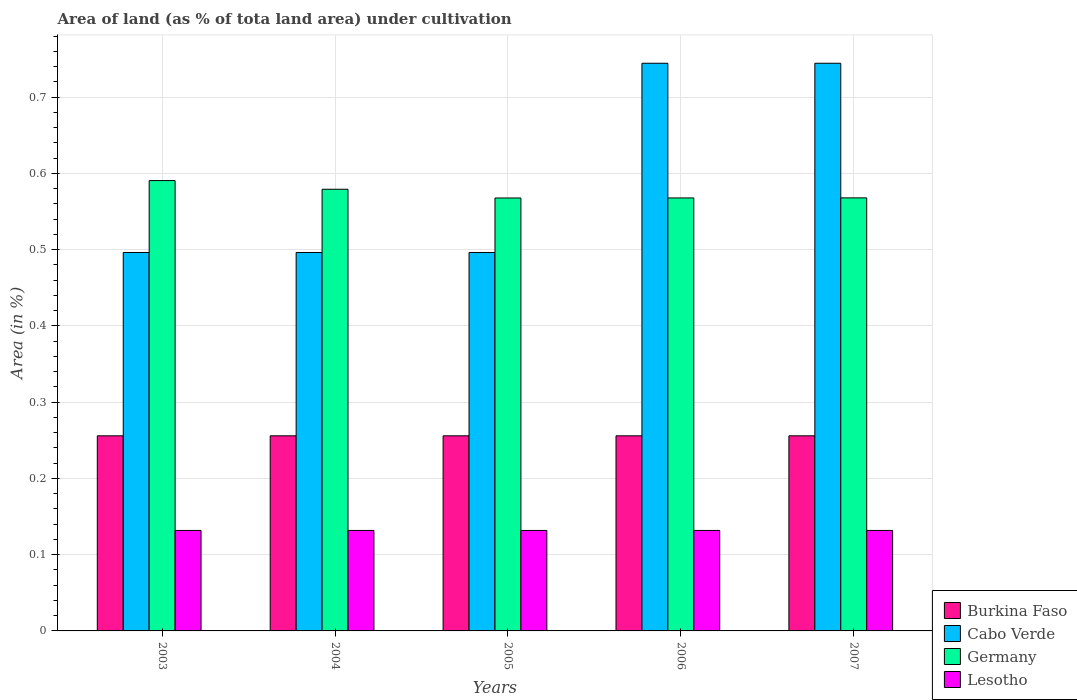How many different coloured bars are there?
Give a very brief answer. 4. Are the number of bars on each tick of the X-axis equal?
Make the answer very short. Yes. How many bars are there on the 1st tick from the right?
Make the answer very short. 4. What is the label of the 2nd group of bars from the left?
Provide a short and direct response. 2004. In how many cases, is the number of bars for a given year not equal to the number of legend labels?
Your answer should be very brief. 0. What is the percentage of land under cultivation in Lesotho in 2007?
Provide a succinct answer. 0.13. Across all years, what is the maximum percentage of land under cultivation in Cabo Verde?
Keep it short and to the point. 0.74. Across all years, what is the minimum percentage of land under cultivation in Cabo Verde?
Give a very brief answer. 0.5. In which year was the percentage of land under cultivation in Burkina Faso maximum?
Make the answer very short. 2003. What is the total percentage of land under cultivation in Cabo Verde in the graph?
Your response must be concise. 2.98. What is the difference between the percentage of land under cultivation in Germany in 2004 and that in 2006?
Offer a terse response. 0.01. What is the difference between the percentage of land under cultivation in Lesotho in 2005 and the percentage of land under cultivation in Burkina Faso in 2006?
Keep it short and to the point. -0.12. What is the average percentage of land under cultivation in Lesotho per year?
Your response must be concise. 0.13. In the year 2003, what is the difference between the percentage of land under cultivation in Burkina Faso and percentage of land under cultivation in Cabo Verde?
Provide a short and direct response. -0.24. Is the difference between the percentage of land under cultivation in Burkina Faso in 2003 and 2007 greater than the difference between the percentage of land under cultivation in Cabo Verde in 2003 and 2007?
Your answer should be very brief. Yes. What is the difference between the highest and the second highest percentage of land under cultivation in Cabo Verde?
Provide a short and direct response. 0. What is the difference between the highest and the lowest percentage of land under cultivation in Germany?
Make the answer very short. 0.02. In how many years, is the percentage of land under cultivation in Cabo Verde greater than the average percentage of land under cultivation in Cabo Verde taken over all years?
Make the answer very short. 2. Is the sum of the percentage of land under cultivation in Burkina Faso in 2005 and 2007 greater than the maximum percentage of land under cultivation in Cabo Verde across all years?
Give a very brief answer. No. Is it the case that in every year, the sum of the percentage of land under cultivation in Cabo Verde and percentage of land under cultivation in Lesotho is greater than the sum of percentage of land under cultivation in Burkina Faso and percentage of land under cultivation in Germany?
Give a very brief answer. No. What does the 2nd bar from the left in 2006 represents?
Offer a terse response. Cabo Verde. What does the 2nd bar from the right in 2006 represents?
Your answer should be compact. Germany. Are all the bars in the graph horizontal?
Make the answer very short. No. How many years are there in the graph?
Provide a short and direct response. 5. Does the graph contain any zero values?
Your answer should be very brief. No. How are the legend labels stacked?
Give a very brief answer. Vertical. What is the title of the graph?
Make the answer very short. Area of land (as % of tota land area) under cultivation. Does "Spain" appear as one of the legend labels in the graph?
Offer a terse response. No. What is the label or title of the X-axis?
Offer a terse response. Years. What is the label or title of the Y-axis?
Offer a very short reply. Area (in %). What is the Area (in %) of Burkina Faso in 2003?
Your answer should be compact. 0.26. What is the Area (in %) of Cabo Verde in 2003?
Make the answer very short. 0.5. What is the Area (in %) in Germany in 2003?
Keep it short and to the point. 0.59. What is the Area (in %) in Lesotho in 2003?
Offer a terse response. 0.13. What is the Area (in %) in Burkina Faso in 2004?
Offer a terse response. 0.26. What is the Area (in %) in Cabo Verde in 2004?
Provide a succinct answer. 0.5. What is the Area (in %) in Germany in 2004?
Offer a terse response. 0.58. What is the Area (in %) in Lesotho in 2004?
Your answer should be very brief. 0.13. What is the Area (in %) in Burkina Faso in 2005?
Offer a terse response. 0.26. What is the Area (in %) of Cabo Verde in 2005?
Offer a very short reply. 0.5. What is the Area (in %) of Germany in 2005?
Offer a terse response. 0.57. What is the Area (in %) in Lesotho in 2005?
Your answer should be compact. 0.13. What is the Area (in %) of Burkina Faso in 2006?
Your answer should be compact. 0.26. What is the Area (in %) in Cabo Verde in 2006?
Ensure brevity in your answer.  0.74. What is the Area (in %) in Germany in 2006?
Offer a very short reply. 0.57. What is the Area (in %) of Lesotho in 2006?
Ensure brevity in your answer.  0.13. What is the Area (in %) of Burkina Faso in 2007?
Offer a terse response. 0.26. What is the Area (in %) of Cabo Verde in 2007?
Provide a short and direct response. 0.74. What is the Area (in %) of Germany in 2007?
Your answer should be compact. 0.57. What is the Area (in %) in Lesotho in 2007?
Offer a very short reply. 0.13. Across all years, what is the maximum Area (in %) of Burkina Faso?
Keep it short and to the point. 0.26. Across all years, what is the maximum Area (in %) in Cabo Verde?
Provide a short and direct response. 0.74. Across all years, what is the maximum Area (in %) of Germany?
Give a very brief answer. 0.59. Across all years, what is the maximum Area (in %) of Lesotho?
Your answer should be very brief. 0.13. Across all years, what is the minimum Area (in %) in Burkina Faso?
Provide a short and direct response. 0.26. Across all years, what is the minimum Area (in %) in Cabo Verde?
Your response must be concise. 0.5. Across all years, what is the minimum Area (in %) in Germany?
Make the answer very short. 0.57. Across all years, what is the minimum Area (in %) in Lesotho?
Offer a terse response. 0.13. What is the total Area (in %) of Burkina Faso in the graph?
Ensure brevity in your answer.  1.28. What is the total Area (in %) in Cabo Verde in the graph?
Provide a short and direct response. 2.98. What is the total Area (in %) of Germany in the graph?
Make the answer very short. 2.87. What is the total Area (in %) in Lesotho in the graph?
Provide a succinct answer. 0.66. What is the difference between the Area (in %) in Burkina Faso in 2003 and that in 2004?
Give a very brief answer. 0. What is the difference between the Area (in %) of Cabo Verde in 2003 and that in 2004?
Offer a terse response. 0. What is the difference between the Area (in %) in Germany in 2003 and that in 2004?
Offer a terse response. 0.01. What is the difference between the Area (in %) in Lesotho in 2003 and that in 2004?
Ensure brevity in your answer.  0. What is the difference between the Area (in %) in Germany in 2003 and that in 2005?
Offer a terse response. 0.02. What is the difference between the Area (in %) of Lesotho in 2003 and that in 2005?
Offer a terse response. 0. What is the difference between the Area (in %) of Cabo Verde in 2003 and that in 2006?
Offer a terse response. -0.25. What is the difference between the Area (in %) in Germany in 2003 and that in 2006?
Your answer should be compact. 0.02. What is the difference between the Area (in %) of Lesotho in 2003 and that in 2006?
Keep it short and to the point. 0. What is the difference between the Area (in %) in Cabo Verde in 2003 and that in 2007?
Make the answer very short. -0.25. What is the difference between the Area (in %) of Germany in 2003 and that in 2007?
Your answer should be very brief. 0.02. What is the difference between the Area (in %) in Germany in 2004 and that in 2005?
Make the answer very short. 0.01. What is the difference between the Area (in %) of Lesotho in 2004 and that in 2005?
Give a very brief answer. 0. What is the difference between the Area (in %) of Burkina Faso in 2004 and that in 2006?
Make the answer very short. 0. What is the difference between the Area (in %) in Cabo Verde in 2004 and that in 2006?
Your answer should be compact. -0.25. What is the difference between the Area (in %) in Germany in 2004 and that in 2006?
Offer a terse response. 0.01. What is the difference between the Area (in %) of Lesotho in 2004 and that in 2006?
Your response must be concise. 0. What is the difference between the Area (in %) in Burkina Faso in 2004 and that in 2007?
Keep it short and to the point. 0. What is the difference between the Area (in %) of Cabo Verde in 2004 and that in 2007?
Offer a very short reply. -0.25. What is the difference between the Area (in %) of Germany in 2004 and that in 2007?
Offer a terse response. 0.01. What is the difference between the Area (in %) in Cabo Verde in 2005 and that in 2006?
Offer a terse response. -0.25. What is the difference between the Area (in %) in Germany in 2005 and that in 2006?
Provide a succinct answer. -0. What is the difference between the Area (in %) of Lesotho in 2005 and that in 2006?
Ensure brevity in your answer.  0. What is the difference between the Area (in %) of Burkina Faso in 2005 and that in 2007?
Ensure brevity in your answer.  0. What is the difference between the Area (in %) in Cabo Verde in 2005 and that in 2007?
Ensure brevity in your answer.  -0.25. What is the difference between the Area (in %) of Germany in 2005 and that in 2007?
Offer a terse response. -0. What is the difference between the Area (in %) of Germany in 2006 and that in 2007?
Provide a short and direct response. -0. What is the difference between the Area (in %) of Lesotho in 2006 and that in 2007?
Your response must be concise. 0. What is the difference between the Area (in %) in Burkina Faso in 2003 and the Area (in %) in Cabo Verde in 2004?
Ensure brevity in your answer.  -0.24. What is the difference between the Area (in %) in Burkina Faso in 2003 and the Area (in %) in Germany in 2004?
Offer a terse response. -0.32. What is the difference between the Area (in %) of Burkina Faso in 2003 and the Area (in %) of Lesotho in 2004?
Offer a very short reply. 0.12. What is the difference between the Area (in %) in Cabo Verde in 2003 and the Area (in %) in Germany in 2004?
Your answer should be very brief. -0.08. What is the difference between the Area (in %) in Cabo Verde in 2003 and the Area (in %) in Lesotho in 2004?
Provide a succinct answer. 0.36. What is the difference between the Area (in %) in Germany in 2003 and the Area (in %) in Lesotho in 2004?
Your answer should be compact. 0.46. What is the difference between the Area (in %) in Burkina Faso in 2003 and the Area (in %) in Cabo Verde in 2005?
Offer a terse response. -0.24. What is the difference between the Area (in %) of Burkina Faso in 2003 and the Area (in %) of Germany in 2005?
Your response must be concise. -0.31. What is the difference between the Area (in %) of Burkina Faso in 2003 and the Area (in %) of Lesotho in 2005?
Provide a succinct answer. 0.12. What is the difference between the Area (in %) of Cabo Verde in 2003 and the Area (in %) of Germany in 2005?
Make the answer very short. -0.07. What is the difference between the Area (in %) in Cabo Verde in 2003 and the Area (in %) in Lesotho in 2005?
Make the answer very short. 0.36. What is the difference between the Area (in %) in Germany in 2003 and the Area (in %) in Lesotho in 2005?
Ensure brevity in your answer.  0.46. What is the difference between the Area (in %) in Burkina Faso in 2003 and the Area (in %) in Cabo Verde in 2006?
Provide a short and direct response. -0.49. What is the difference between the Area (in %) in Burkina Faso in 2003 and the Area (in %) in Germany in 2006?
Provide a short and direct response. -0.31. What is the difference between the Area (in %) of Burkina Faso in 2003 and the Area (in %) of Lesotho in 2006?
Your response must be concise. 0.12. What is the difference between the Area (in %) in Cabo Verde in 2003 and the Area (in %) in Germany in 2006?
Your answer should be compact. -0.07. What is the difference between the Area (in %) in Cabo Verde in 2003 and the Area (in %) in Lesotho in 2006?
Your response must be concise. 0.36. What is the difference between the Area (in %) of Germany in 2003 and the Area (in %) of Lesotho in 2006?
Your answer should be very brief. 0.46. What is the difference between the Area (in %) of Burkina Faso in 2003 and the Area (in %) of Cabo Verde in 2007?
Offer a very short reply. -0.49. What is the difference between the Area (in %) in Burkina Faso in 2003 and the Area (in %) in Germany in 2007?
Make the answer very short. -0.31. What is the difference between the Area (in %) in Burkina Faso in 2003 and the Area (in %) in Lesotho in 2007?
Provide a succinct answer. 0.12. What is the difference between the Area (in %) of Cabo Verde in 2003 and the Area (in %) of Germany in 2007?
Your answer should be compact. -0.07. What is the difference between the Area (in %) in Cabo Verde in 2003 and the Area (in %) in Lesotho in 2007?
Give a very brief answer. 0.36. What is the difference between the Area (in %) of Germany in 2003 and the Area (in %) of Lesotho in 2007?
Provide a short and direct response. 0.46. What is the difference between the Area (in %) in Burkina Faso in 2004 and the Area (in %) in Cabo Verde in 2005?
Your answer should be very brief. -0.24. What is the difference between the Area (in %) in Burkina Faso in 2004 and the Area (in %) in Germany in 2005?
Offer a very short reply. -0.31. What is the difference between the Area (in %) in Burkina Faso in 2004 and the Area (in %) in Lesotho in 2005?
Give a very brief answer. 0.12. What is the difference between the Area (in %) of Cabo Verde in 2004 and the Area (in %) of Germany in 2005?
Offer a very short reply. -0.07. What is the difference between the Area (in %) of Cabo Verde in 2004 and the Area (in %) of Lesotho in 2005?
Provide a short and direct response. 0.36. What is the difference between the Area (in %) of Germany in 2004 and the Area (in %) of Lesotho in 2005?
Your answer should be very brief. 0.45. What is the difference between the Area (in %) of Burkina Faso in 2004 and the Area (in %) of Cabo Verde in 2006?
Give a very brief answer. -0.49. What is the difference between the Area (in %) of Burkina Faso in 2004 and the Area (in %) of Germany in 2006?
Your answer should be very brief. -0.31. What is the difference between the Area (in %) of Burkina Faso in 2004 and the Area (in %) of Lesotho in 2006?
Offer a terse response. 0.12. What is the difference between the Area (in %) of Cabo Verde in 2004 and the Area (in %) of Germany in 2006?
Your answer should be compact. -0.07. What is the difference between the Area (in %) of Cabo Verde in 2004 and the Area (in %) of Lesotho in 2006?
Give a very brief answer. 0.36. What is the difference between the Area (in %) of Germany in 2004 and the Area (in %) of Lesotho in 2006?
Your answer should be compact. 0.45. What is the difference between the Area (in %) in Burkina Faso in 2004 and the Area (in %) in Cabo Verde in 2007?
Your answer should be very brief. -0.49. What is the difference between the Area (in %) of Burkina Faso in 2004 and the Area (in %) of Germany in 2007?
Make the answer very short. -0.31. What is the difference between the Area (in %) in Burkina Faso in 2004 and the Area (in %) in Lesotho in 2007?
Make the answer very short. 0.12. What is the difference between the Area (in %) in Cabo Verde in 2004 and the Area (in %) in Germany in 2007?
Keep it short and to the point. -0.07. What is the difference between the Area (in %) of Cabo Verde in 2004 and the Area (in %) of Lesotho in 2007?
Provide a succinct answer. 0.36. What is the difference between the Area (in %) in Germany in 2004 and the Area (in %) in Lesotho in 2007?
Provide a short and direct response. 0.45. What is the difference between the Area (in %) of Burkina Faso in 2005 and the Area (in %) of Cabo Verde in 2006?
Offer a terse response. -0.49. What is the difference between the Area (in %) in Burkina Faso in 2005 and the Area (in %) in Germany in 2006?
Give a very brief answer. -0.31. What is the difference between the Area (in %) in Burkina Faso in 2005 and the Area (in %) in Lesotho in 2006?
Make the answer very short. 0.12. What is the difference between the Area (in %) in Cabo Verde in 2005 and the Area (in %) in Germany in 2006?
Your answer should be very brief. -0.07. What is the difference between the Area (in %) in Cabo Verde in 2005 and the Area (in %) in Lesotho in 2006?
Your response must be concise. 0.36. What is the difference between the Area (in %) in Germany in 2005 and the Area (in %) in Lesotho in 2006?
Keep it short and to the point. 0.44. What is the difference between the Area (in %) of Burkina Faso in 2005 and the Area (in %) of Cabo Verde in 2007?
Offer a terse response. -0.49. What is the difference between the Area (in %) in Burkina Faso in 2005 and the Area (in %) in Germany in 2007?
Give a very brief answer. -0.31. What is the difference between the Area (in %) of Burkina Faso in 2005 and the Area (in %) of Lesotho in 2007?
Give a very brief answer. 0.12. What is the difference between the Area (in %) in Cabo Verde in 2005 and the Area (in %) in Germany in 2007?
Your answer should be compact. -0.07. What is the difference between the Area (in %) in Cabo Verde in 2005 and the Area (in %) in Lesotho in 2007?
Give a very brief answer. 0.36. What is the difference between the Area (in %) of Germany in 2005 and the Area (in %) of Lesotho in 2007?
Give a very brief answer. 0.44. What is the difference between the Area (in %) of Burkina Faso in 2006 and the Area (in %) of Cabo Verde in 2007?
Give a very brief answer. -0.49. What is the difference between the Area (in %) in Burkina Faso in 2006 and the Area (in %) in Germany in 2007?
Your answer should be very brief. -0.31. What is the difference between the Area (in %) in Burkina Faso in 2006 and the Area (in %) in Lesotho in 2007?
Ensure brevity in your answer.  0.12. What is the difference between the Area (in %) of Cabo Verde in 2006 and the Area (in %) of Germany in 2007?
Offer a terse response. 0.18. What is the difference between the Area (in %) of Cabo Verde in 2006 and the Area (in %) of Lesotho in 2007?
Your answer should be very brief. 0.61. What is the difference between the Area (in %) of Germany in 2006 and the Area (in %) of Lesotho in 2007?
Provide a succinct answer. 0.44. What is the average Area (in %) of Burkina Faso per year?
Your response must be concise. 0.26. What is the average Area (in %) of Cabo Verde per year?
Provide a succinct answer. 0.6. What is the average Area (in %) of Germany per year?
Offer a very short reply. 0.57. What is the average Area (in %) in Lesotho per year?
Offer a very short reply. 0.13. In the year 2003, what is the difference between the Area (in %) of Burkina Faso and Area (in %) of Cabo Verde?
Give a very brief answer. -0.24. In the year 2003, what is the difference between the Area (in %) in Burkina Faso and Area (in %) in Germany?
Offer a very short reply. -0.33. In the year 2003, what is the difference between the Area (in %) in Burkina Faso and Area (in %) in Lesotho?
Your answer should be very brief. 0.12. In the year 2003, what is the difference between the Area (in %) of Cabo Verde and Area (in %) of Germany?
Your response must be concise. -0.09. In the year 2003, what is the difference between the Area (in %) in Cabo Verde and Area (in %) in Lesotho?
Make the answer very short. 0.36. In the year 2003, what is the difference between the Area (in %) in Germany and Area (in %) in Lesotho?
Offer a very short reply. 0.46. In the year 2004, what is the difference between the Area (in %) in Burkina Faso and Area (in %) in Cabo Verde?
Make the answer very short. -0.24. In the year 2004, what is the difference between the Area (in %) in Burkina Faso and Area (in %) in Germany?
Your response must be concise. -0.32. In the year 2004, what is the difference between the Area (in %) of Burkina Faso and Area (in %) of Lesotho?
Ensure brevity in your answer.  0.12. In the year 2004, what is the difference between the Area (in %) in Cabo Verde and Area (in %) in Germany?
Keep it short and to the point. -0.08. In the year 2004, what is the difference between the Area (in %) of Cabo Verde and Area (in %) of Lesotho?
Your answer should be very brief. 0.36. In the year 2004, what is the difference between the Area (in %) in Germany and Area (in %) in Lesotho?
Your answer should be very brief. 0.45. In the year 2005, what is the difference between the Area (in %) in Burkina Faso and Area (in %) in Cabo Verde?
Your answer should be compact. -0.24. In the year 2005, what is the difference between the Area (in %) in Burkina Faso and Area (in %) in Germany?
Your answer should be compact. -0.31. In the year 2005, what is the difference between the Area (in %) in Burkina Faso and Area (in %) in Lesotho?
Your answer should be very brief. 0.12. In the year 2005, what is the difference between the Area (in %) in Cabo Verde and Area (in %) in Germany?
Ensure brevity in your answer.  -0.07. In the year 2005, what is the difference between the Area (in %) in Cabo Verde and Area (in %) in Lesotho?
Give a very brief answer. 0.36. In the year 2005, what is the difference between the Area (in %) in Germany and Area (in %) in Lesotho?
Offer a very short reply. 0.44. In the year 2006, what is the difference between the Area (in %) in Burkina Faso and Area (in %) in Cabo Verde?
Provide a short and direct response. -0.49. In the year 2006, what is the difference between the Area (in %) in Burkina Faso and Area (in %) in Germany?
Make the answer very short. -0.31. In the year 2006, what is the difference between the Area (in %) of Burkina Faso and Area (in %) of Lesotho?
Your response must be concise. 0.12. In the year 2006, what is the difference between the Area (in %) in Cabo Verde and Area (in %) in Germany?
Offer a terse response. 0.18. In the year 2006, what is the difference between the Area (in %) of Cabo Verde and Area (in %) of Lesotho?
Make the answer very short. 0.61. In the year 2006, what is the difference between the Area (in %) in Germany and Area (in %) in Lesotho?
Keep it short and to the point. 0.44. In the year 2007, what is the difference between the Area (in %) in Burkina Faso and Area (in %) in Cabo Verde?
Give a very brief answer. -0.49. In the year 2007, what is the difference between the Area (in %) of Burkina Faso and Area (in %) of Germany?
Your answer should be very brief. -0.31. In the year 2007, what is the difference between the Area (in %) in Burkina Faso and Area (in %) in Lesotho?
Provide a succinct answer. 0.12. In the year 2007, what is the difference between the Area (in %) of Cabo Verde and Area (in %) of Germany?
Make the answer very short. 0.18. In the year 2007, what is the difference between the Area (in %) in Cabo Verde and Area (in %) in Lesotho?
Offer a very short reply. 0.61. In the year 2007, what is the difference between the Area (in %) in Germany and Area (in %) in Lesotho?
Ensure brevity in your answer.  0.44. What is the ratio of the Area (in %) in Germany in 2003 to that in 2004?
Your response must be concise. 1.02. What is the ratio of the Area (in %) in Lesotho in 2003 to that in 2004?
Your response must be concise. 1. What is the ratio of the Area (in %) of Burkina Faso in 2003 to that in 2005?
Ensure brevity in your answer.  1. What is the ratio of the Area (in %) of Cabo Verde in 2003 to that in 2005?
Provide a short and direct response. 1. What is the ratio of the Area (in %) of Germany in 2003 to that in 2005?
Make the answer very short. 1.04. What is the ratio of the Area (in %) of Lesotho in 2003 to that in 2005?
Your answer should be very brief. 1. What is the ratio of the Area (in %) in Cabo Verde in 2003 to that in 2006?
Provide a succinct answer. 0.67. What is the ratio of the Area (in %) of Germany in 2003 to that in 2006?
Provide a succinct answer. 1.04. What is the ratio of the Area (in %) of Cabo Verde in 2003 to that in 2007?
Your answer should be very brief. 0.67. What is the ratio of the Area (in %) of Burkina Faso in 2004 to that in 2005?
Ensure brevity in your answer.  1. What is the ratio of the Area (in %) in Germany in 2004 to that in 2005?
Your answer should be very brief. 1.02. What is the ratio of the Area (in %) in Germany in 2004 to that in 2006?
Your answer should be compact. 1.02. What is the ratio of the Area (in %) in Cabo Verde in 2004 to that in 2007?
Your answer should be very brief. 0.67. What is the ratio of the Area (in %) in Germany in 2004 to that in 2007?
Give a very brief answer. 1.02. What is the ratio of the Area (in %) of Lesotho in 2004 to that in 2007?
Ensure brevity in your answer.  1. What is the ratio of the Area (in %) of Burkina Faso in 2005 to that in 2006?
Ensure brevity in your answer.  1. What is the ratio of the Area (in %) of Cabo Verde in 2005 to that in 2006?
Give a very brief answer. 0.67. What is the ratio of the Area (in %) in Germany in 2005 to that in 2006?
Your answer should be very brief. 1. What is the ratio of the Area (in %) of Lesotho in 2005 to that in 2007?
Your answer should be very brief. 1. What is the difference between the highest and the second highest Area (in %) of Cabo Verde?
Provide a short and direct response. 0. What is the difference between the highest and the second highest Area (in %) of Germany?
Give a very brief answer. 0.01. What is the difference between the highest and the second highest Area (in %) in Lesotho?
Give a very brief answer. 0. What is the difference between the highest and the lowest Area (in %) in Burkina Faso?
Your answer should be very brief. 0. What is the difference between the highest and the lowest Area (in %) of Cabo Verde?
Offer a very short reply. 0.25. What is the difference between the highest and the lowest Area (in %) of Germany?
Provide a short and direct response. 0.02. 